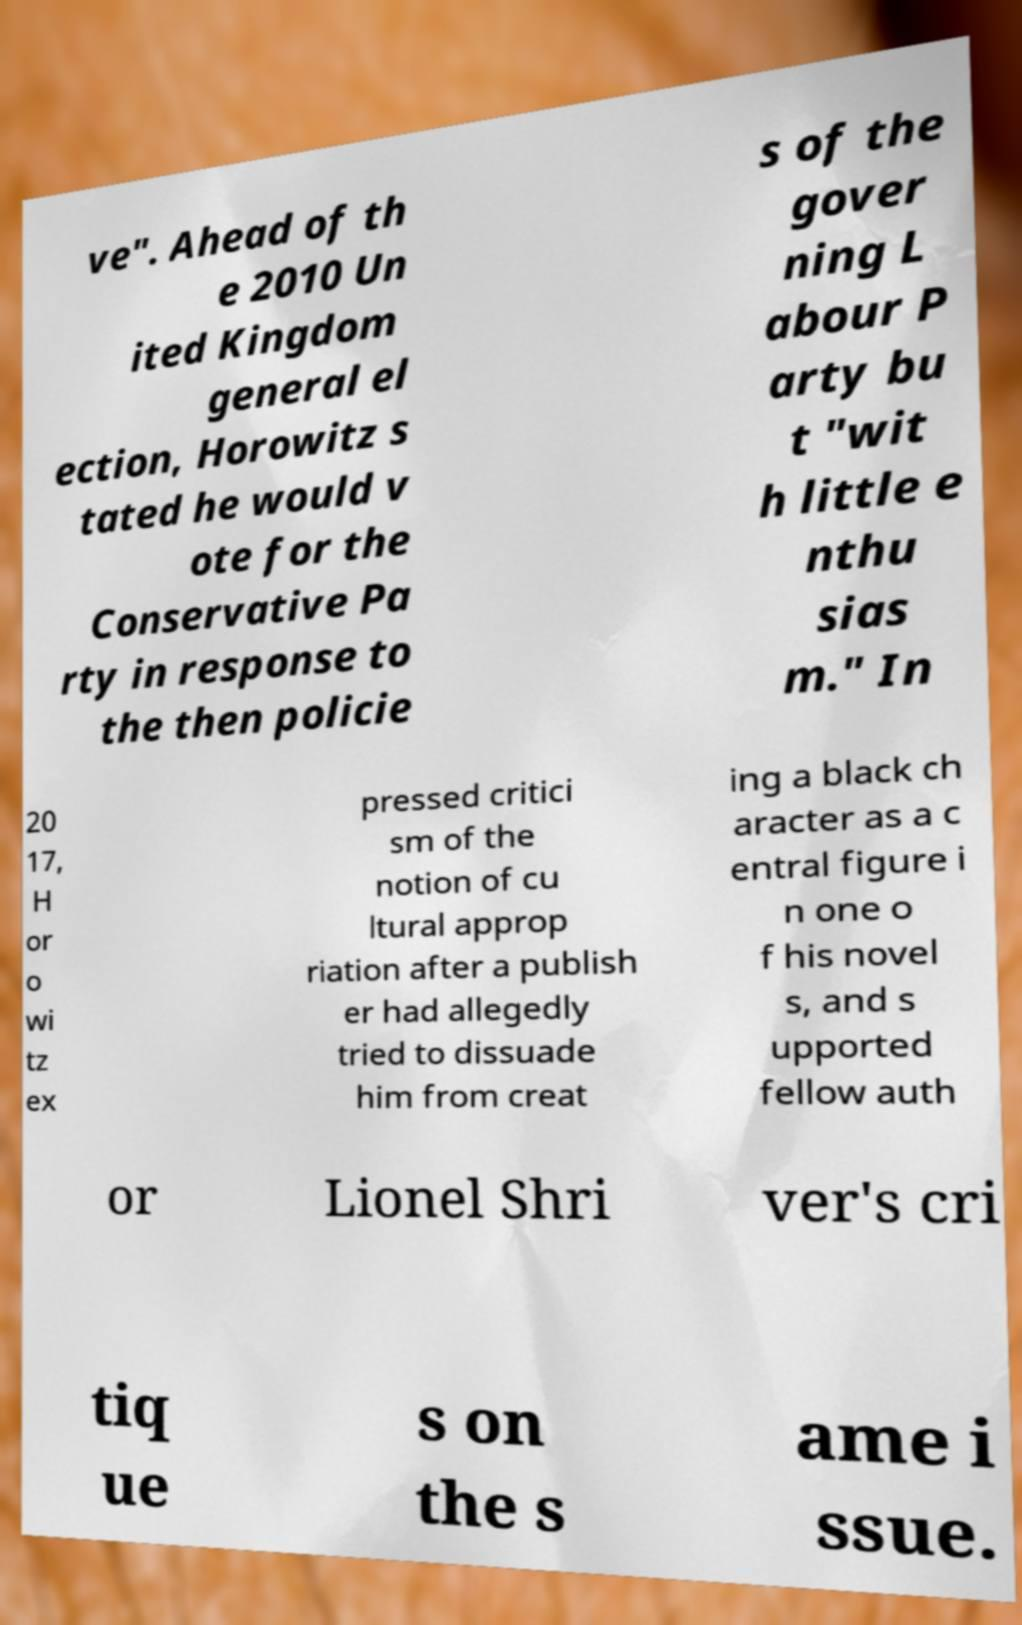Can you read and provide the text displayed in the image?This photo seems to have some interesting text. Can you extract and type it out for me? ve". Ahead of th e 2010 Un ited Kingdom general el ection, Horowitz s tated he would v ote for the Conservative Pa rty in response to the then policie s of the gover ning L abour P arty bu t "wit h little e nthu sias m." In 20 17, H or o wi tz ex pressed critici sm of the notion of cu ltural approp riation after a publish er had allegedly tried to dissuade him from creat ing a black ch aracter as a c entral figure i n one o f his novel s, and s upported fellow auth or Lionel Shri ver's cri tiq ue s on the s ame i ssue. 